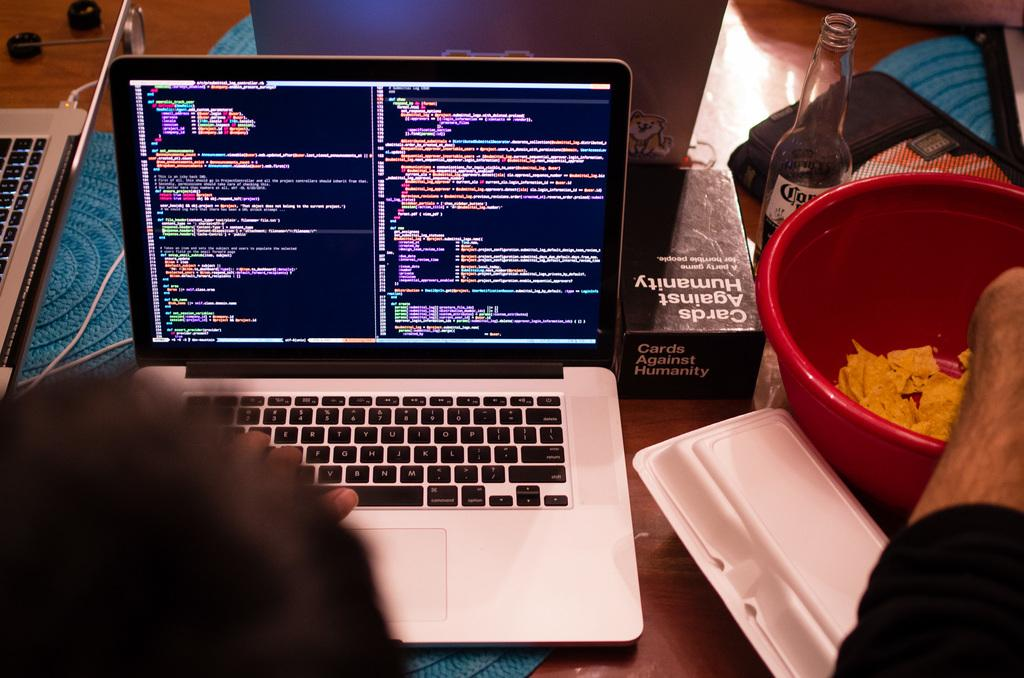Provide a one-sentence caption for the provided image. Cards of Humanity card game next to a laptop on a table. 